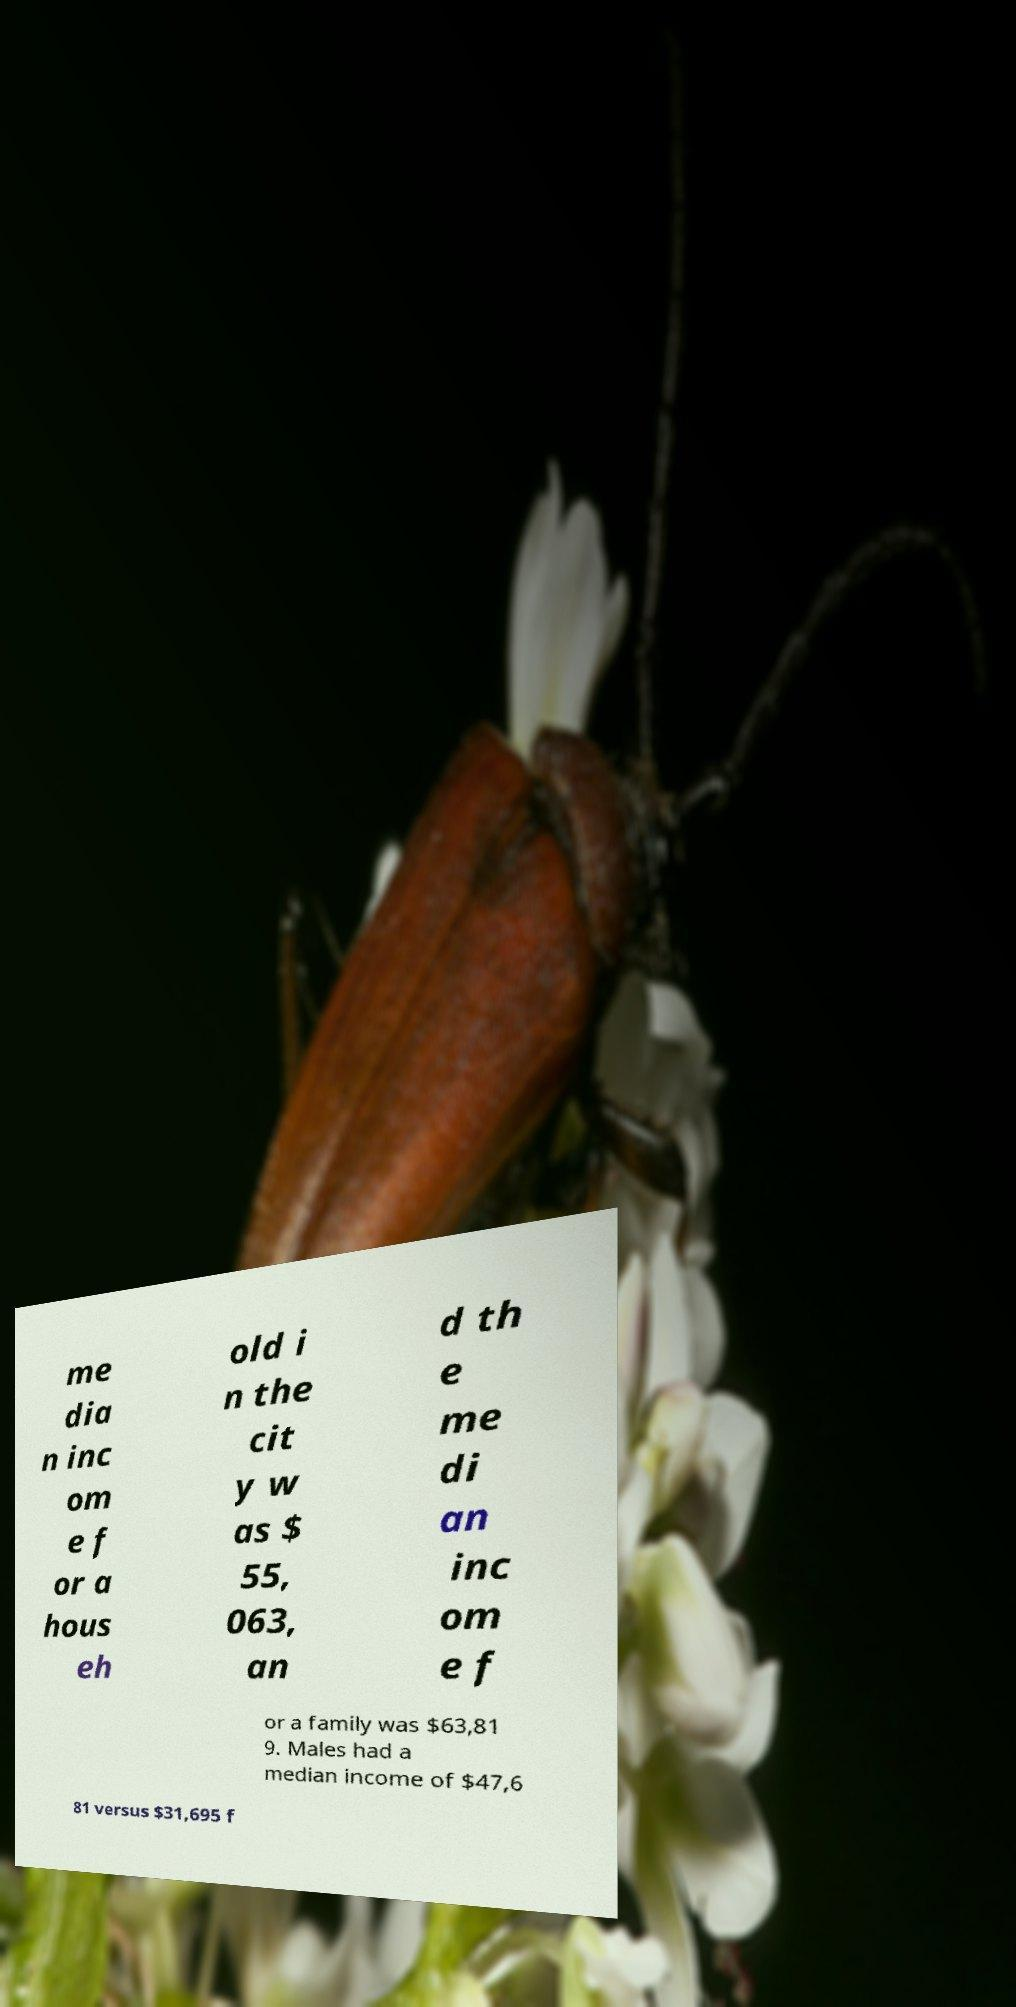Please identify and transcribe the text found in this image. me dia n inc om e f or a hous eh old i n the cit y w as $ 55, 063, an d th e me di an inc om e f or a family was $63,81 9. Males had a median income of $47,6 81 versus $31,695 f 